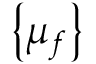Convert formula to latex. <formula><loc_0><loc_0><loc_500><loc_500>\left \{ \mu _ { f } \right \}</formula> 